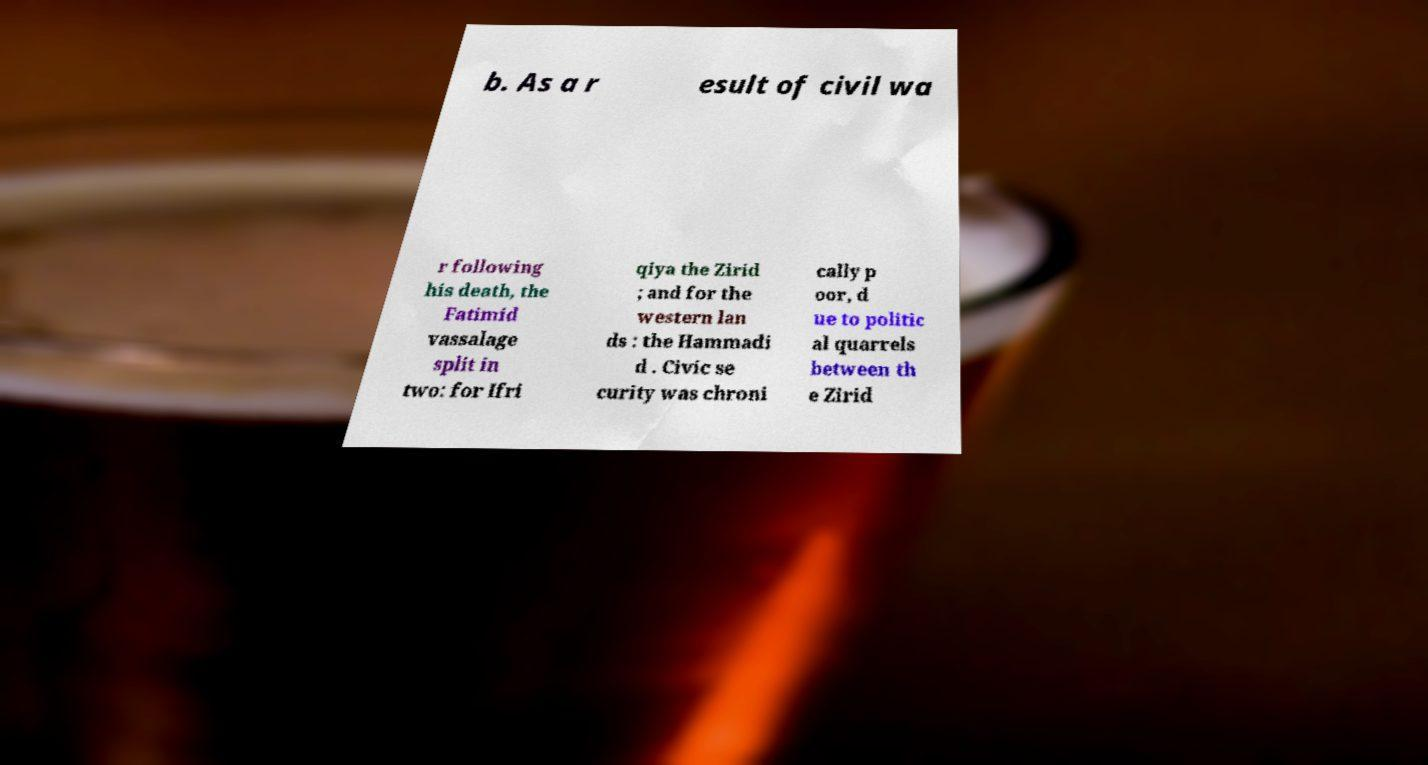Could you extract and type out the text from this image? b. As a r esult of civil wa r following his death, the Fatimid vassalage split in two: for Ifri qiya the Zirid ; and for the western lan ds : the Hammadi d . Civic se curity was chroni cally p oor, d ue to politic al quarrels between th e Zirid 